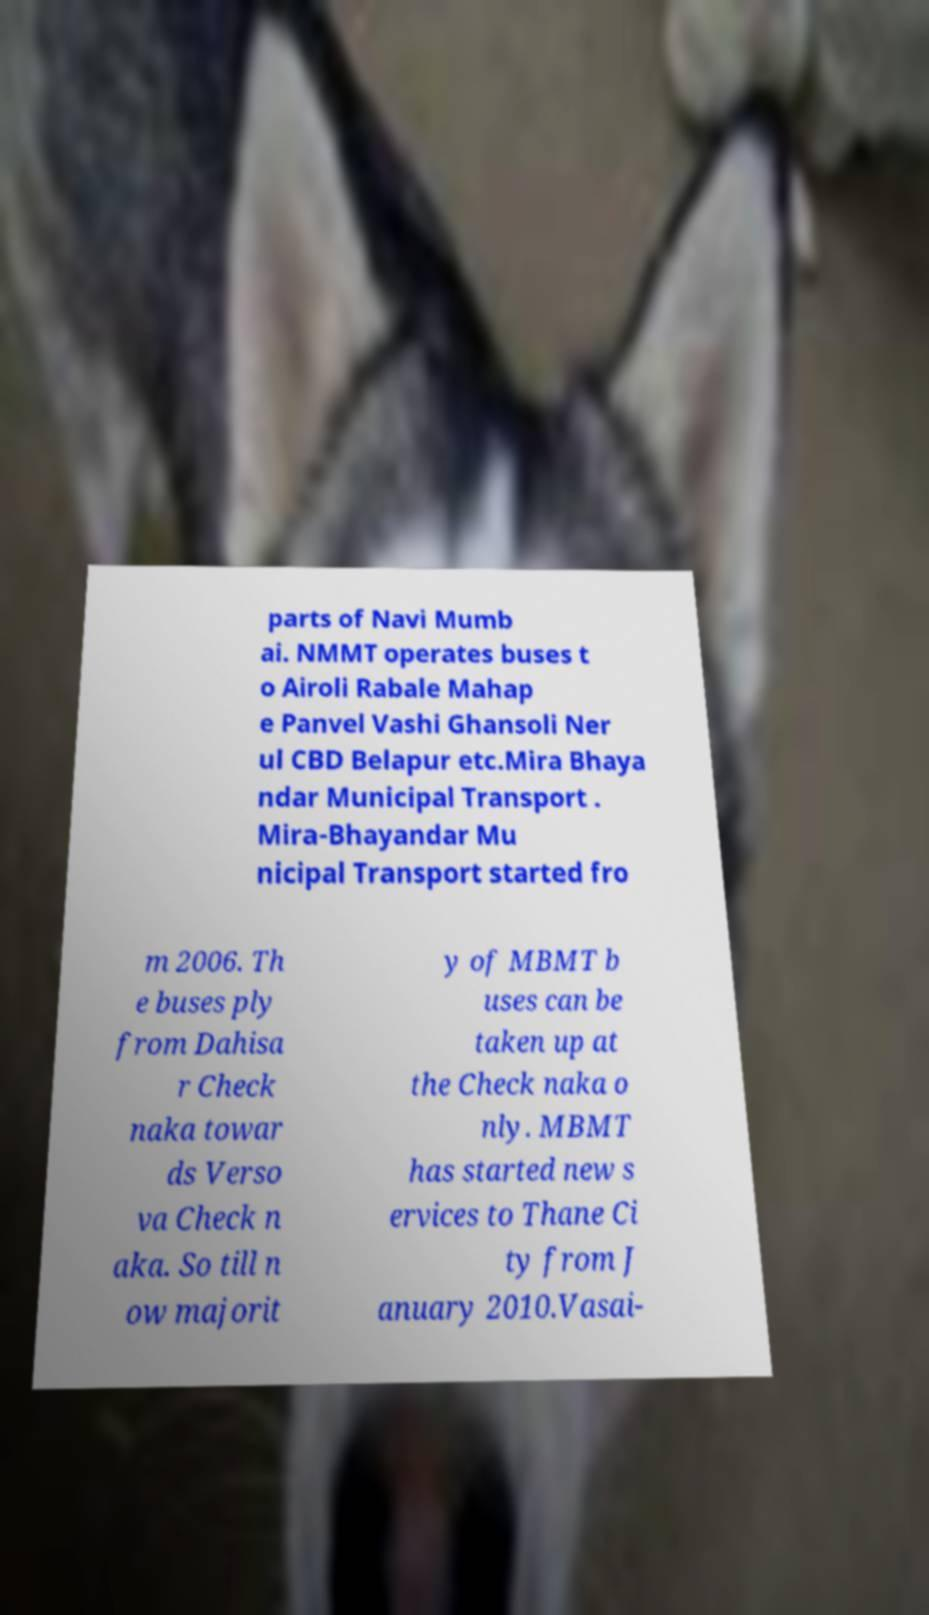There's text embedded in this image that I need extracted. Can you transcribe it verbatim? parts of Navi Mumb ai. NMMT operates buses t o Airoli Rabale Mahap e Panvel Vashi Ghansoli Ner ul CBD Belapur etc.Mira Bhaya ndar Municipal Transport . Mira-Bhayandar Mu nicipal Transport started fro m 2006. Th e buses ply from Dahisa r Check naka towar ds Verso va Check n aka. So till n ow majorit y of MBMT b uses can be taken up at the Check naka o nly. MBMT has started new s ervices to Thane Ci ty from J anuary 2010.Vasai- 